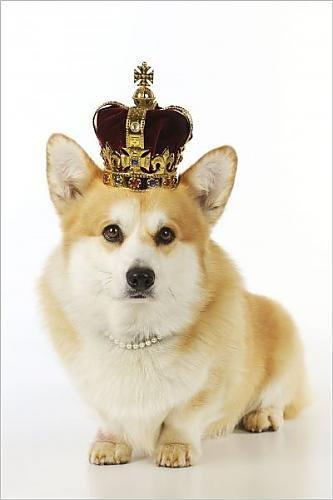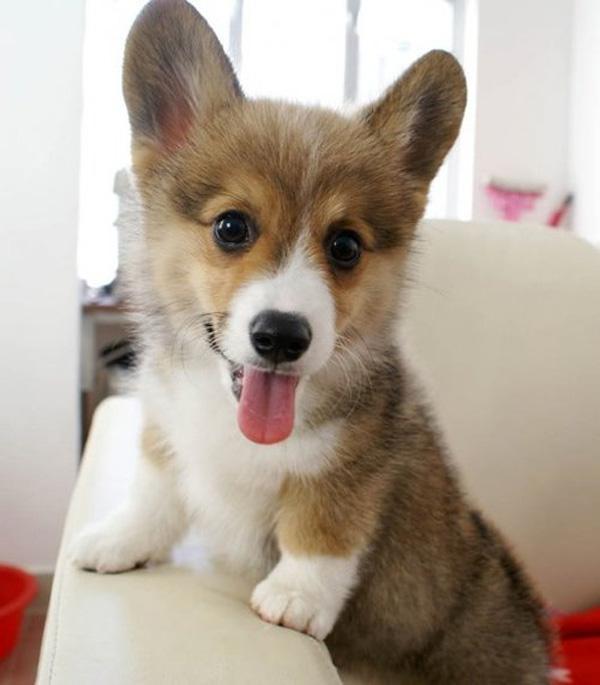The first image is the image on the left, the second image is the image on the right. Given the left and right images, does the statement "An image includes a corgi pup with one ear upright and the ear on the left flopping forward." hold true? Answer yes or no. No. The first image is the image on the left, the second image is the image on the right. Evaluate the accuracy of this statement regarding the images: "There's exactly two dogs in the left image.". Is it true? Answer yes or no. No. 